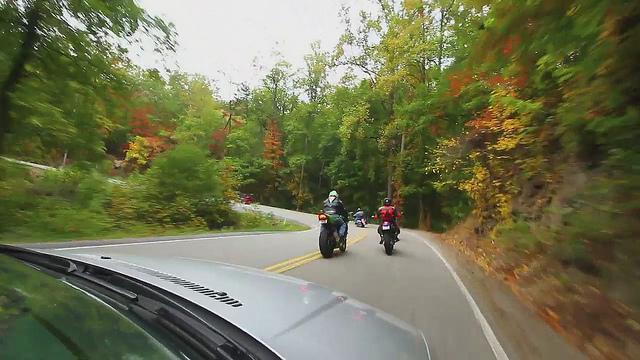How many people are on the road?
Give a very brief answer. 4. 